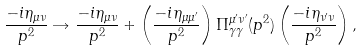<formula> <loc_0><loc_0><loc_500><loc_500>\frac { - i \eta _ { \mu \nu } } { p ^ { 2 } } \rightarrow \frac { - i \eta _ { \mu \nu } } { p ^ { 2 } } + \left ( \frac { - i \eta _ { \mu \mu ^ { \prime } } } { p ^ { 2 } } \right ) \Pi ^ { \mu ^ { \prime } \nu ^ { \prime } } _ { \gamma \gamma } ( p ^ { 2 } ) \left ( \frac { - i \eta _ { \nu ^ { \prime } \nu } } { p ^ { 2 } } \right ) ,</formula> 